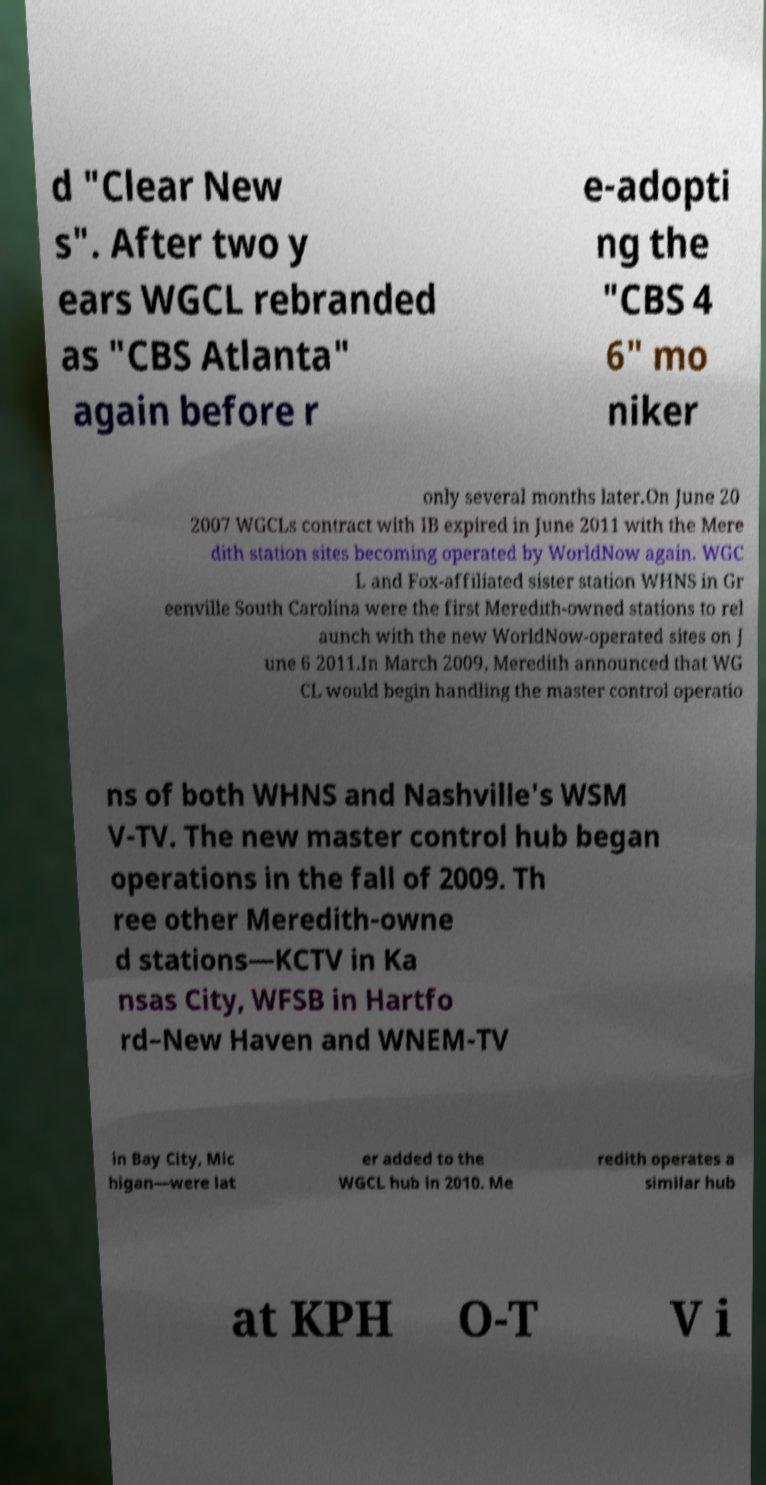There's text embedded in this image that I need extracted. Can you transcribe it verbatim? d "Clear New s". After two y ears WGCL rebranded as "CBS Atlanta" again before r e-adopti ng the "CBS 4 6" mo niker only several months later.On June 20 2007 WGCLs contract with IB expired in June 2011 with the Mere dith station sites becoming operated by WorldNow again. WGC L and Fox-affiliated sister station WHNS in Gr eenville South Carolina were the first Meredith-owned stations to rel aunch with the new WorldNow-operated sites on J une 6 2011.In March 2009, Meredith announced that WG CL would begin handling the master control operatio ns of both WHNS and Nashville's WSM V-TV. The new master control hub began operations in the fall of 2009. Th ree other Meredith-owne d stations—KCTV in Ka nsas City, WFSB in Hartfo rd–New Haven and WNEM-TV in Bay City, Mic higan—were lat er added to the WGCL hub in 2010. Me redith operates a similar hub at KPH O-T V i 